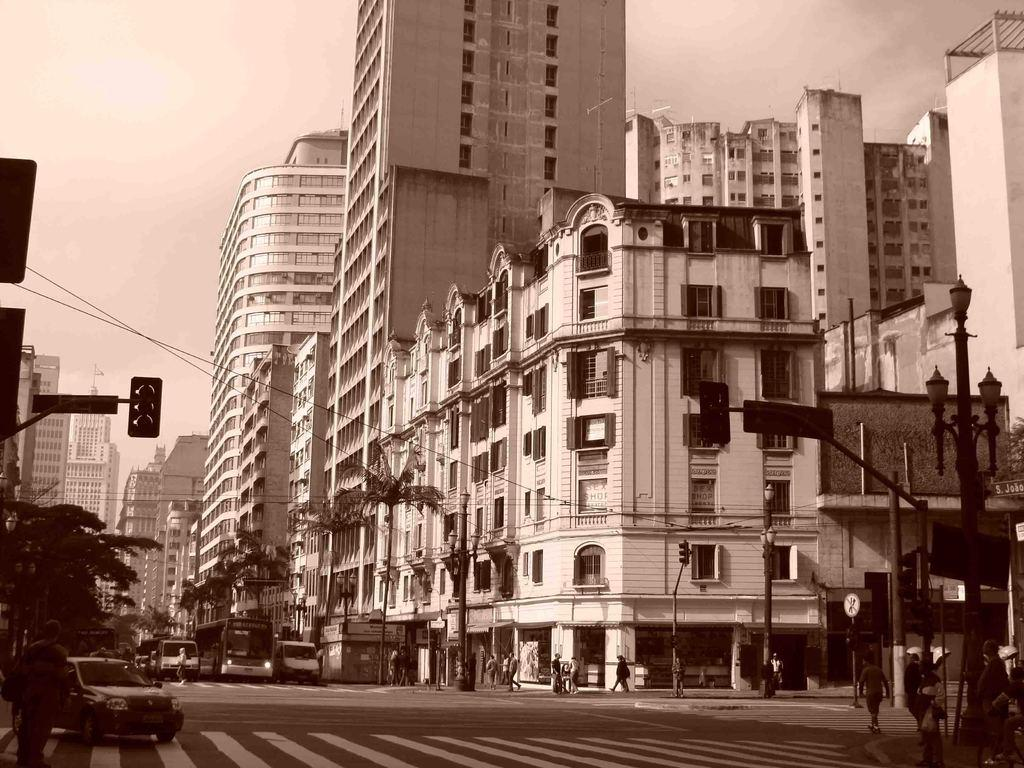What is happening on the road in the image? There are vehicles on the road in the image. What else can be seen in the image besides vehicles? There are people walking in the image, and there is a traffic signal. What type of structures are visible in the image? There are buildings in the image. What is visible in the background of the image? The sky is visible in the image. How is the image presented in terms of color? The image is in black and white. How many beasts are present in the image? There are no beasts present in the image. What type of spade is being used by the people walking in the image? There is no spade visible in the image; people are walking without any tools. 